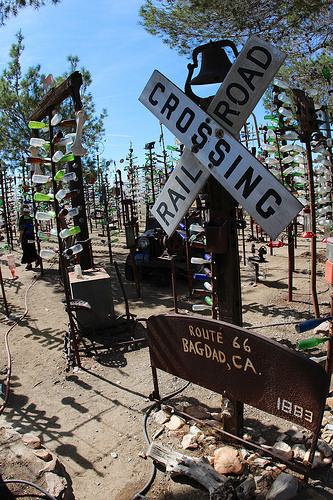<image>
Can you confirm if the bottle is on the pole? Yes. Looking at the image, I can see the bottle is positioned on top of the pole, with the pole providing support. Is there a bottle on the pole? Yes. Looking at the image, I can see the bottle is positioned on top of the pole, with the pole providing support. Is there a bell behind the sign? Yes. From this viewpoint, the bell is positioned behind the sign, with the sign partially or fully occluding the bell. 